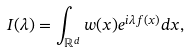<formula> <loc_0><loc_0><loc_500><loc_500>I ( \lambda ) = \int _ { \mathbb { R } ^ { d } } w ( x ) e ^ { i \lambda f ( x ) } d x ,</formula> 